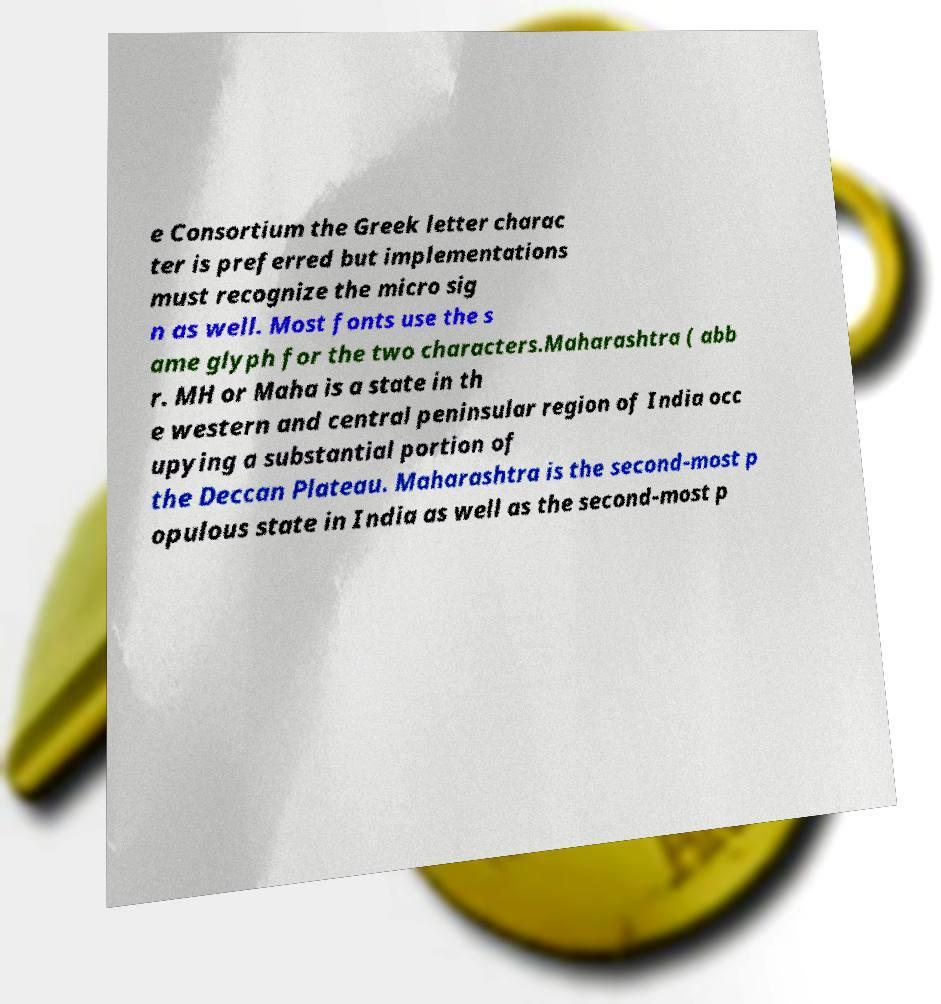Can you accurately transcribe the text from the provided image for me? e Consortium the Greek letter charac ter is preferred but implementations must recognize the micro sig n as well. Most fonts use the s ame glyph for the two characters.Maharashtra ( abb r. MH or Maha is a state in th e western and central peninsular region of India occ upying a substantial portion of the Deccan Plateau. Maharashtra is the second-most p opulous state in India as well as the second-most p 